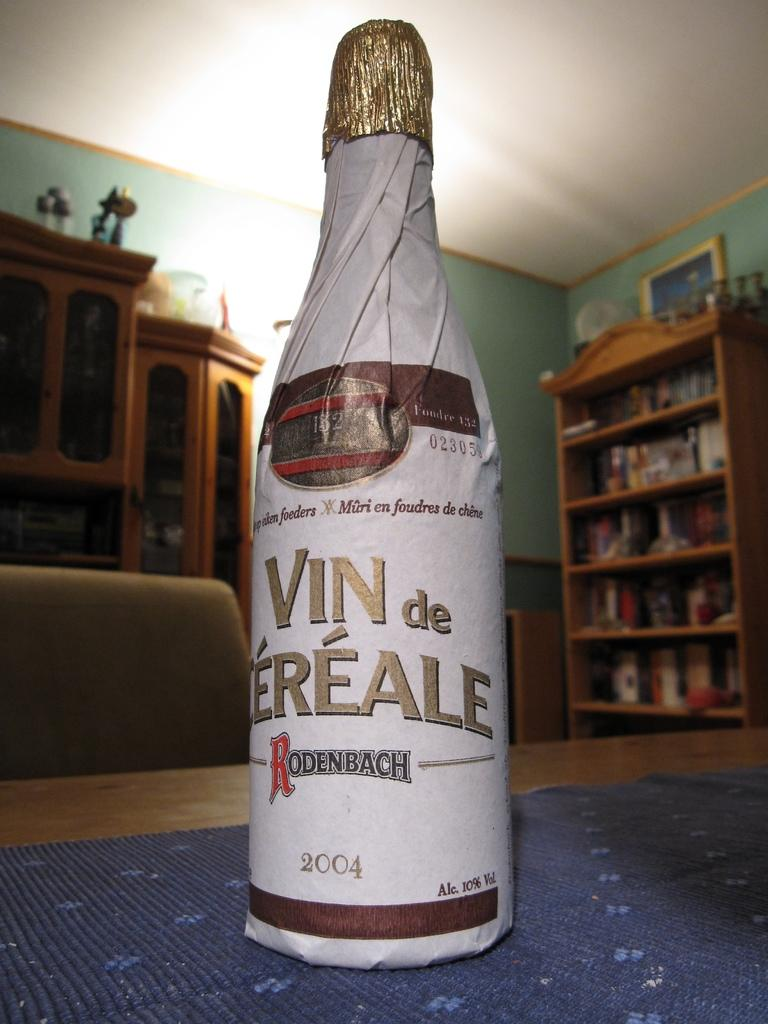<image>
Summarize the visual content of the image. A bottle of champagne with he brand name Rodenbach. 